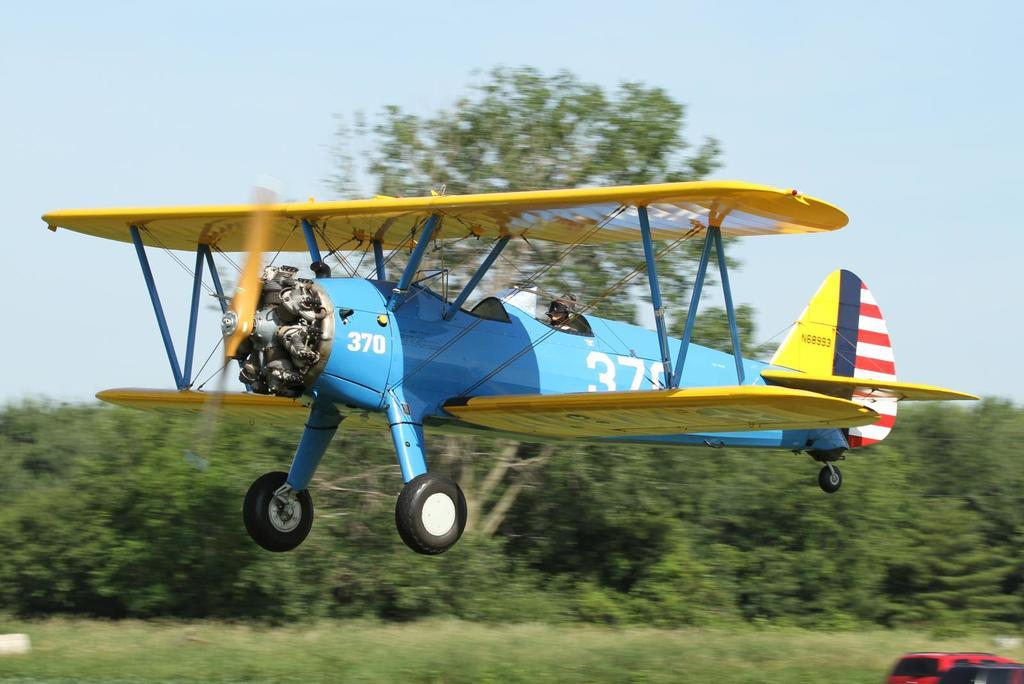<image>
Summarize the visual content of the image. a blue and yellow prop plane with number 37 on the side 